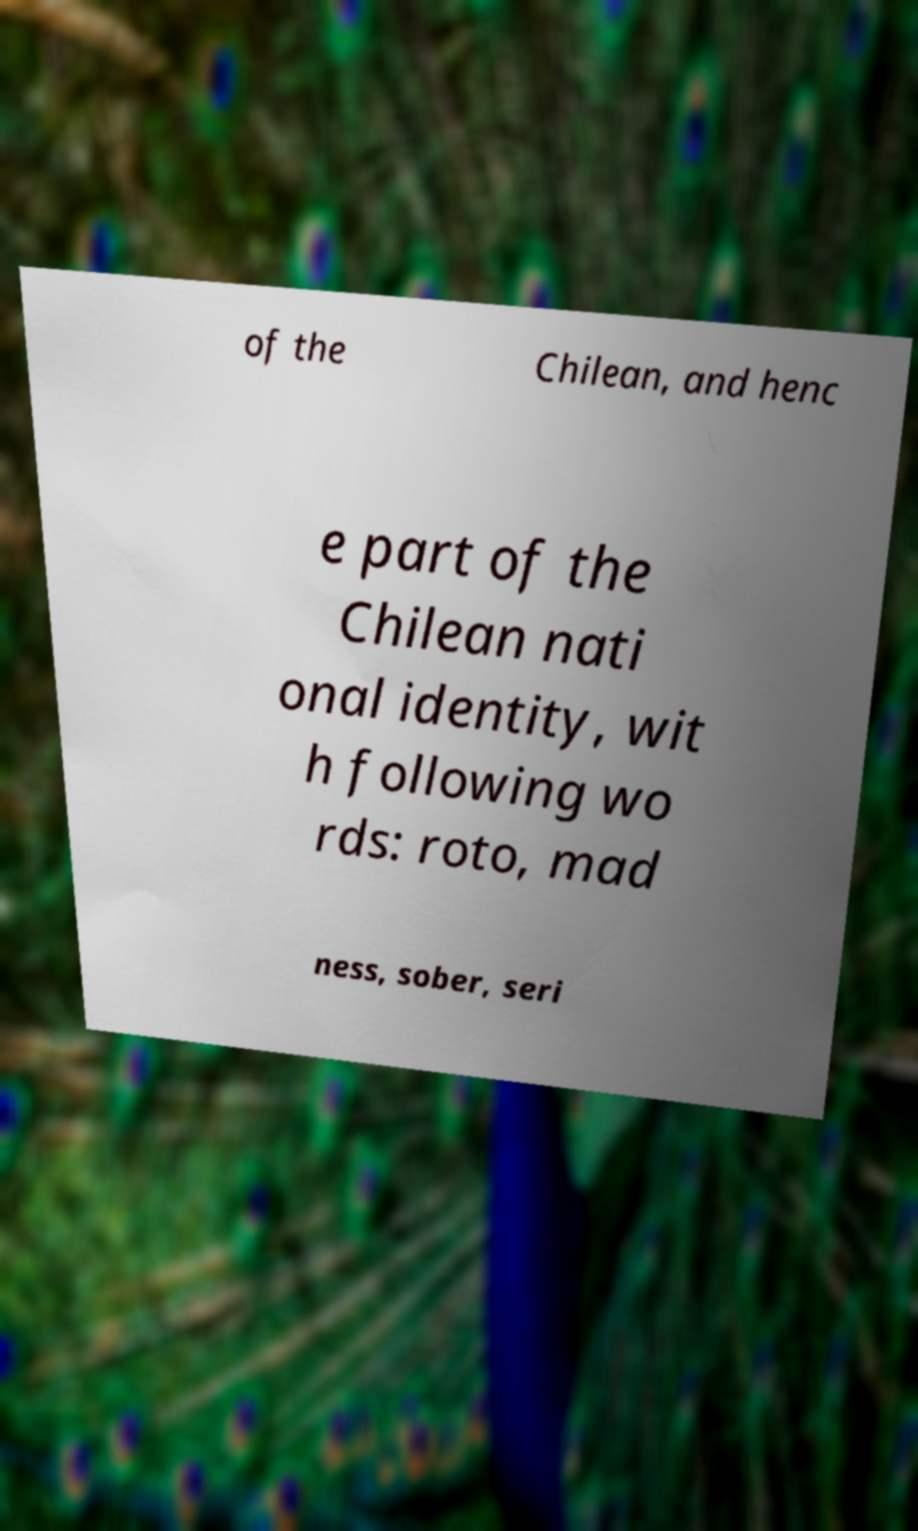For documentation purposes, I need the text within this image transcribed. Could you provide that? of the Chilean, and henc e part of the Chilean nati onal identity, wit h following wo rds: roto, mad ness, sober, seri 